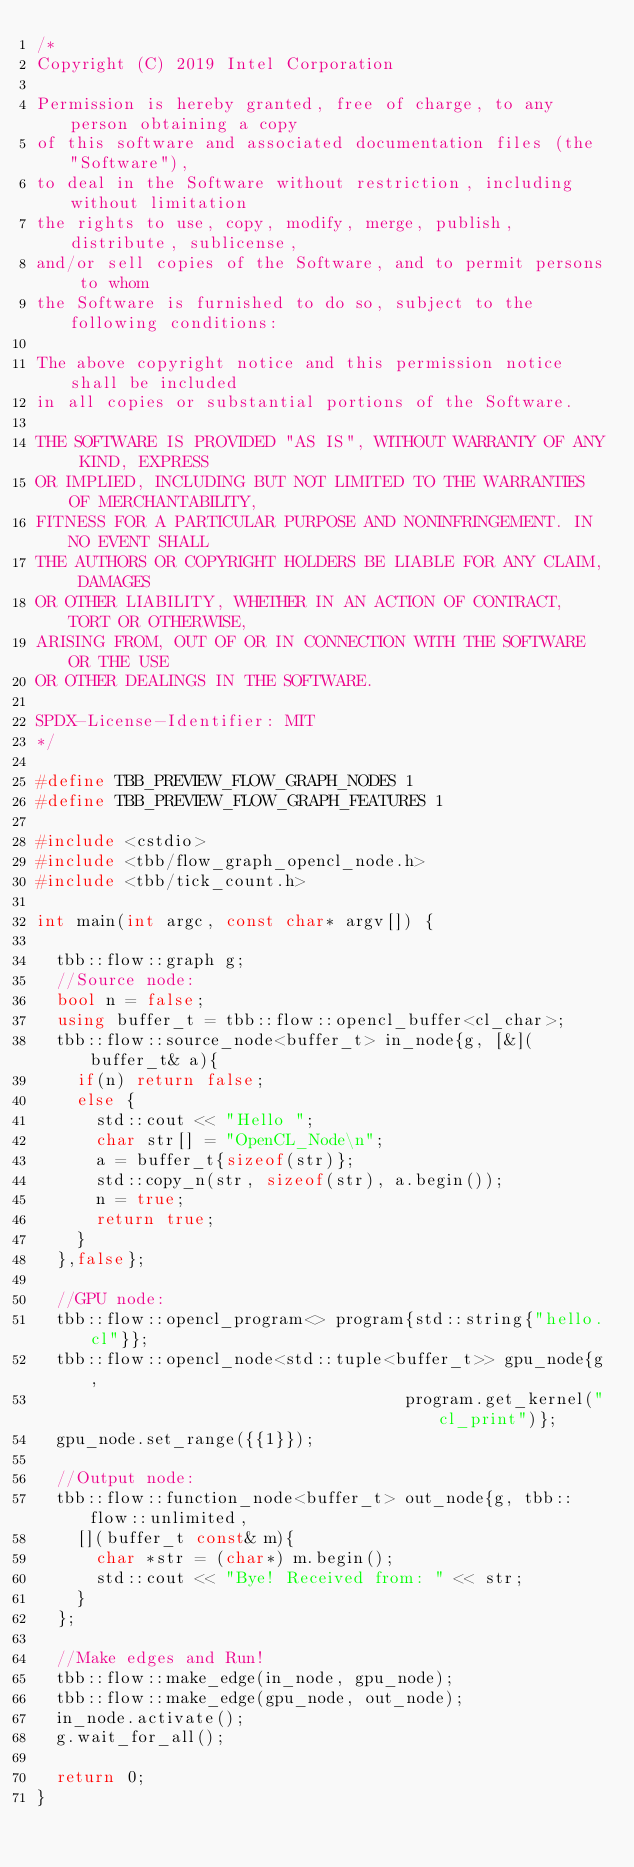Convert code to text. <code><loc_0><loc_0><loc_500><loc_500><_C++_>/*
Copyright (C) 2019 Intel Corporation

Permission is hereby granted, free of charge, to any person obtaining a copy
of this software and associated documentation files (the "Software"),
to deal in the Software without restriction, including without limitation
the rights to use, copy, modify, merge, publish, distribute, sublicense,
and/or sell copies of the Software, and to permit persons to whom
the Software is furnished to do so, subject to the following conditions:

The above copyright notice and this permission notice shall be included
in all copies or substantial portions of the Software.

THE SOFTWARE IS PROVIDED "AS IS", WITHOUT WARRANTY OF ANY KIND, EXPRESS
OR IMPLIED, INCLUDING BUT NOT LIMITED TO THE WARRANTIES OF MERCHANTABILITY,
FITNESS FOR A PARTICULAR PURPOSE AND NONINFRINGEMENT. IN NO EVENT SHALL
THE AUTHORS OR COPYRIGHT HOLDERS BE LIABLE FOR ANY CLAIM, DAMAGES
OR OTHER LIABILITY, WHETHER IN AN ACTION OF CONTRACT, TORT OR OTHERWISE,
ARISING FROM, OUT OF OR IN CONNECTION WITH THE SOFTWARE OR THE USE
OR OTHER DEALINGS IN THE SOFTWARE.

SPDX-License-Identifier: MIT
*/

#define TBB_PREVIEW_FLOW_GRAPH_NODES 1
#define TBB_PREVIEW_FLOW_GRAPH_FEATURES 1

#include <cstdio>
#include <tbb/flow_graph_opencl_node.h>
#include <tbb/tick_count.h>

int main(int argc, const char* argv[]) {

  tbb::flow::graph g;
  //Source node:
  bool n = false;
  using buffer_t = tbb::flow::opencl_buffer<cl_char>;
  tbb::flow::source_node<buffer_t> in_node{g, [&](buffer_t& a){
    if(n) return false;
    else {
      std::cout << "Hello ";
      char str[] = "OpenCL_Node\n";
      a = buffer_t{sizeof(str)};
      std::copy_n(str, sizeof(str), a.begin());
      n = true;
      return true;
    }
  },false};

  //GPU node:
  tbb::flow::opencl_program<> program{std::string{"hello.cl"}};
  tbb::flow::opencl_node<std::tuple<buffer_t>> gpu_node{g,
                                     program.get_kernel("cl_print")};
  gpu_node.set_range({{1}});

  //Output node:
  tbb::flow::function_node<buffer_t> out_node{g, tbb::flow::unlimited,
    [](buffer_t const& m){
      char *str = (char*) m.begin();
      std::cout << "Bye! Received from: " << str;
    }
  };

  //Make edges and Run!
  tbb::flow::make_edge(in_node, gpu_node);
  tbb::flow::make_edge(gpu_node, out_node);
  in_node.activate();
  g.wait_for_all();

  return 0;
}
</code> 